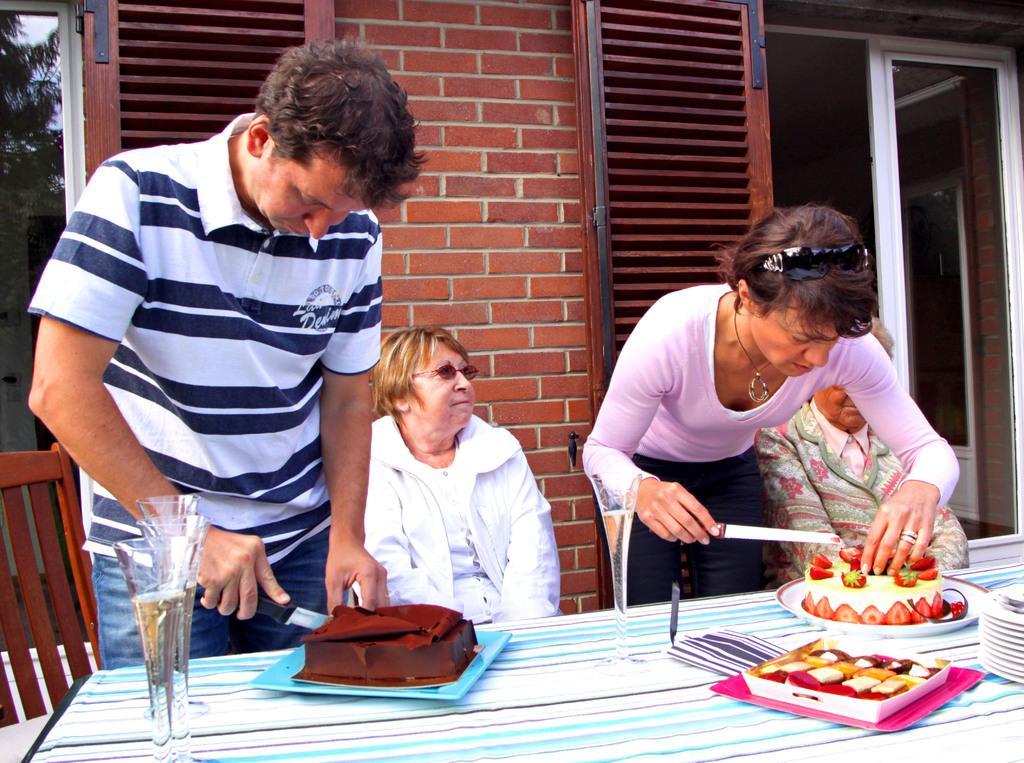Could you give a brief overview of what you see in this image? In this picture we can see two persons sitting on the chairs and these are standing and cutting the cake. This is the table and there is a cloth on the table. These are the glasses and there are some plates. And in the background there is a brick wall and this is the door. Here we can see a tree. 